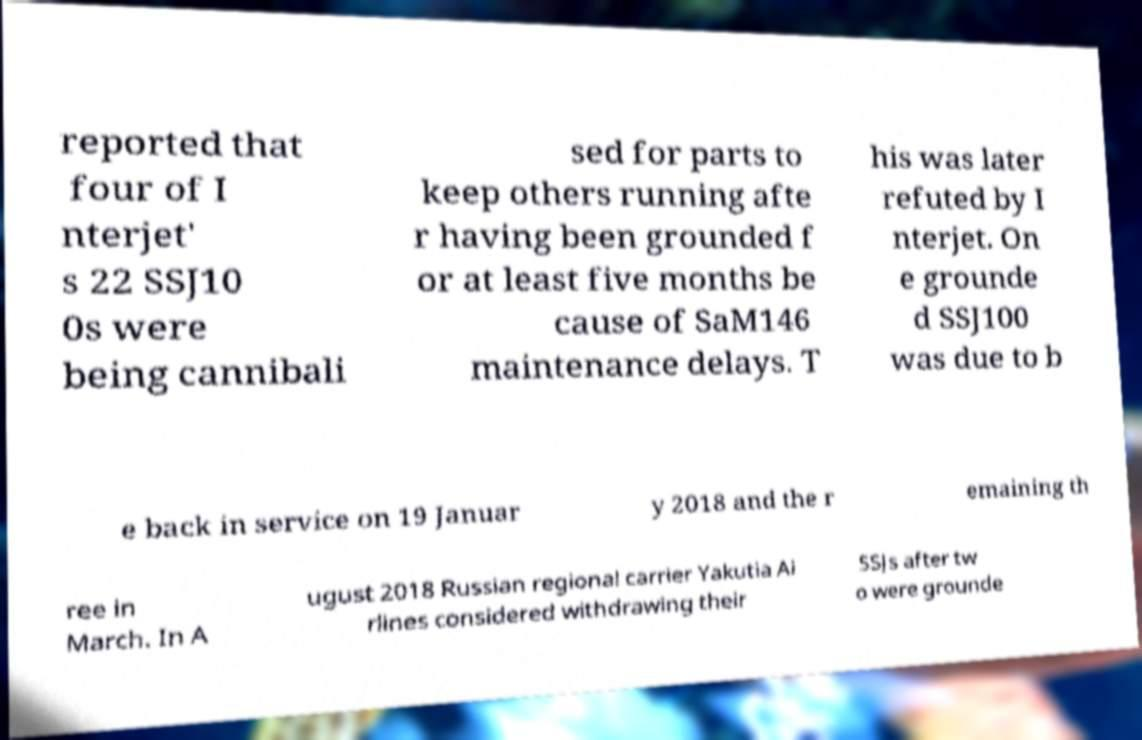I need the written content from this picture converted into text. Can you do that? reported that four of I nterjet' s 22 SSJ10 0s were being cannibali sed for parts to keep others running afte r having been grounded f or at least five months be cause of SaM146 maintenance delays. T his was later refuted by I nterjet. On e grounde d SSJ100 was due to b e back in service on 19 Januar y 2018 and the r emaining th ree in March. In A ugust 2018 Russian regional carrier Yakutia Ai rlines considered withdrawing their SSJs after tw o were grounde 